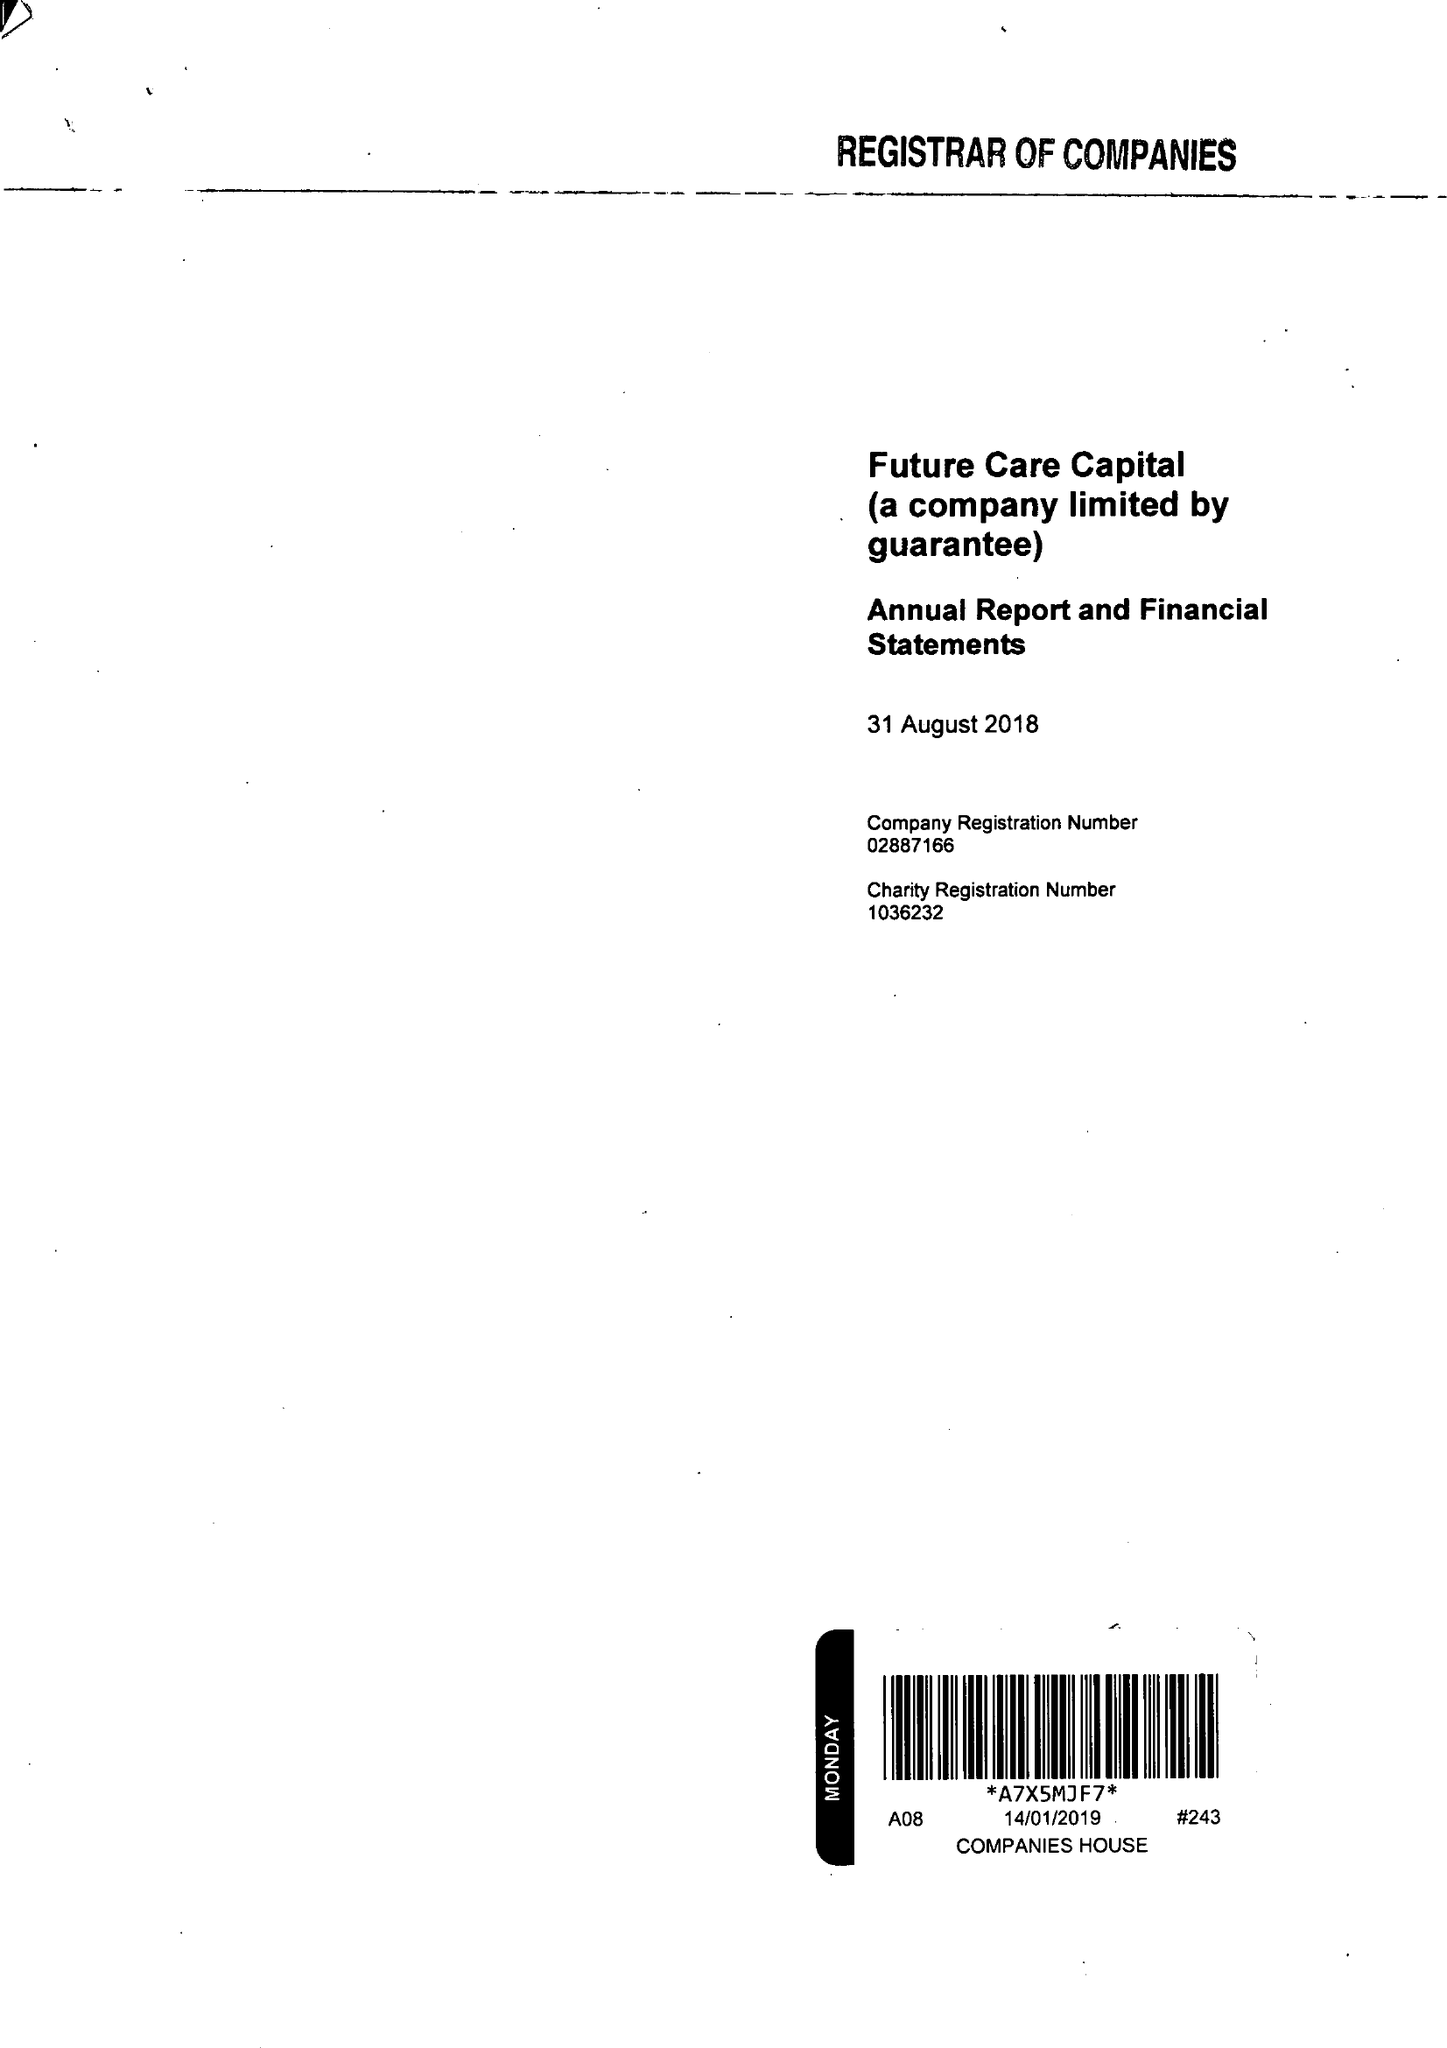What is the value for the charity_number?
Answer the question using a single word or phrase. 1036232 